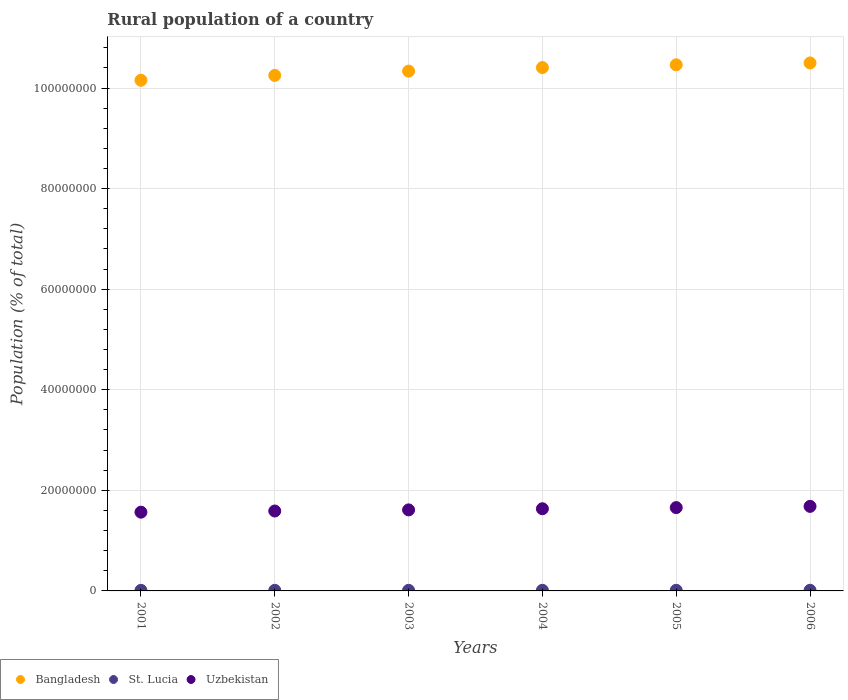How many different coloured dotlines are there?
Keep it short and to the point. 3. Is the number of dotlines equal to the number of legend labels?
Keep it short and to the point. Yes. What is the rural population in Bangladesh in 2004?
Make the answer very short. 1.04e+08. Across all years, what is the maximum rural population in St. Lucia?
Give a very brief answer. 1.31e+05. Across all years, what is the minimum rural population in Bangladesh?
Offer a terse response. 1.02e+08. In which year was the rural population in Bangladesh maximum?
Provide a short and direct response. 2006. What is the total rural population in Bangladesh in the graph?
Make the answer very short. 6.21e+08. What is the difference between the rural population in Bangladesh in 2002 and that in 2005?
Provide a short and direct response. -2.11e+06. What is the difference between the rural population in Uzbekistan in 2006 and the rural population in St. Lucia in 2005?
Your response must be concise. 1.67e+07. What is the average rural population in Uzbekistan per year?
Provide a short and direct response. 1.62e+07. In the year 2003, what is the difference between the rural population in Bangladesh and rural population in St. Lucia?
Your answer should be compact. 1.03e+08. In how many years, is the rural population in Uzbekistan greater than 84000000 %?
Your response must be concise. 0. What is the ratio of the rural population in Bangladesh in 2005 to that in 2006?
Your response must be concise. 1. Is the difference between the rural population in Bangladesh in 2004 and 2006 greater than the difference between the rural population in St. Lucia in 2004 and 2006?
Give a very brief answer. No. What is the difference between the highest and the second highest rural population in St. Lucia?
Ensure brevity in your answer.  3435. What is the difference between the highest and the lowest rural population in Uzbekistan?
Your response must be concise. 1.15e+06. Does the rural population in Bangladesh monotonically increase over the years?
Offer a terse response. Yes. How many years are there in the graph?
Make the answer very short. 6. Are the values on the major ticks of Y-axis written in scientific E-notation?
Your answer should be compact. No. Where does the legend appear in the graph?
Offer a terse response. Bottom left. What is the title of the graph?
Provide a succinct answer. Rural population of a country. Does "United Arab Emirates" appear as one of the legend labels in the graph?
Provide a succinct answer. No. What is the label or title of the Y-axis?
Offer a terse response. Population (% of total). What is the Population (% of total) of Bangladesh in 2001?
Provide a short and direct response. 1.02e+08. What is the Population (% of total) of St. Lucia in 2001?
Ensure brevity in your answer.  1.15e+05. What is the Population (% of total) of Uzbekistan in 2001?
Provide a short and direct response. 1.57e+07. What is the Population (% of total) of Bangladesh in 2002?
Ensure brevity in your answer.  1.03e+08. What is the Population (% of total) in St. Lucia in 2002?
Provide a succinct answer. 1.18e+05. What is the Population (% of total) of Uzbekistan in 2002?
Give a very brief answer. 1.59e+07. What is the Population (% of total) of Bangladesh in 2003?
Provide a succinct answer. 1.03e+08. What is the Population (% of total) of St. Lucia in 2003?
Ensure brevity in your answer.  1.21e+05. What is the Population (% of total) in Uzbekistan in 2003?
Keep it short and to the point. 1.61e+07. What is the Population (% of total) in Bangladesh in 2004?
Provide a short and direct response. 1.04e+08. What is the Population (% of total) of St. Lucia in 2004?
Your answer should be very brief. 1.24e+05. What is the Population (% of total) of Uzbekistan in 2004?
Ensure brevity in your answer.  1.63e+07. What is the Population (% of total) of Bangladesh in 2005?
Offer a terse response. 1.05e+08. What is the Population (% of total) in St. Lucia in 2005?
Provide a succinct answer. 1.27e+05. What is the Population (% of total) in Uzbekistan in 2005?
Your response must be concise. 1.66e+07. What is the Population (% of total) in Bangladesh in 2006?
Your answer should be compact. 1.05e+08. What is the Population (% of total) of St. Lucia in 2006?
Provide a succinct answer. 1.31e+05. What is the Population (% of total) of Uzbekistan in 2006?
Provide a succinct answer. 1.68e+07. Across all years, what is the maximum Population (% of total) in Bangladesh?
Your response must be concise. 1.05e+08. Across all years, what is the maximum Population (% of total) of St. Lucia?
Ensure brevity in your answer.  1.31e+05. Across all years, what is the maximum Population (% of total) of Uzbekistan?
Give a very brief answer. 1.68e+07. Across all years, what is the minimum Population (% of total) of Bangladesh?
Make the answer very short. 1.02e+08. Across all years, what is the minimum Population (% of total) in St. Lucia?
Your answer should be very brief. 1.15e+05. Across all years, what is the minimum Population (% of total) of Uzbekistan?
Ensure brevity in your answer.  1.57e+07. What is the total Population (% of total) in Bangladesh in the graph?
Ensure brevity in your answer.  6.21e+08. What is the total Population (% of total) in St. Lucia in the graph?
Provide a succinct answer. 7.36e+05. What is the total Population (% of total) of Uzbekistan in the graph?
Provide a succinct answer. 9.74e+07. What is the difference between the Population (% of total) in Bangladesh in 2001 and that in 2002?
Offer a very short reply. -9.62e+05. What is the difference between the Population (% of total) in St. Lucia in 2001 and that in 2002?
Offer a very short reply. -2970. What is the difference between the Population (% of total) of Uzbekistan in 2001 and that in 2002?
Keep it short and to the point. -2.31e+05. What is the difference between the Population (% of total) in Bangladesh in 2001 and that in 2003?
Provide a short and direct response. -1.81e+06. What is the difference between the Population (% of total) in St. Lucia in 2001 and that in 2003?
Offer a terse response. -5912. What is the difference between the Population (% of total) of Uzbekistan in 2001 and that in 2003?
Keep it short and to the point. -4.56e+05. What is the difference between the Population (% of total) in Bangladesh in 2001 and that in 2004?
Give a very brief answer. -2.52e+06. What is the difference between the Population (% of total) of St. Lucia in 2001 and that in 2004?
Ensure brevity in your answer.  -8950. What is the difference between the Population (% of total) of Uzbekistan in 2001 and that in 2004?
Make the answer very short. -6.81e+05. What is the difference between the Population (% of total) of Bangladesh in 2001 and that in 2005?
Your answer should be compact. -3.07e+06. What is the difference between the Population (% of total) of St. Lucia in 2001 and that in 2005?
Your answer should be very brief. -1.22e+04. What is the difference between the Population (% of total) in Uzbekistan in 2001 and that in 2005?
Provide a succinct answer. -9.12e+05. What is the difference between the Population (% of total) in Bangladesh in 2001 and that in 2006?
Offer a very short reply. -3.44e+06. What is the difference between the Population (% of total) of St. Lucia in 2001 and that in 2006?
Ensure brevity in your answer.  -1.56e+04. What is the difference between the Population (% of total) of Uzbekistan in 2001 and that in 2006?
Provide a short and direct response. -1.15e+06. What is the difference between the Population (% of total) in Bangladesh in 2002 and that in 2003?
Offer a very short reply. -8.52e+05. What is the difference between the Population (% of total) in St. Lucia in 2002 and that in 2003?
Your response must be concise. -2942. What is the difference between the Population (% of total) in Uzbekistan in 2002 and that in 2003?
Your response must be concise. -2.25e+05. What is the difference between the Population (% of total) in Bangladesh in 2002 and that in 2004?
Keep it short and to the point. -1.56e+06. What is the difference between the Population (% of total) of St. Lucia in 2002 and that in 2004?
Your answer should be compact. -5980. What is the difference between the Population (% of total) of Uzbekistan in 2002 and that in 2004?
Provide a short and direct response. -4.50e+05. What is the difference between the Population (% of total) in Bangladesh in 2002 and that in 2005?
Provide a succinct answer. -2.11e+06. What is the difference between the Population (% of total) of St. Lucia in 2002 and that in 2005?
Provide a short and direct response. -9189. What is the difference between the Population (% of total) in Uzbekistan in 2002 and that in 2005?
Make the answer very short. -6.81e+05. What is the difference between the Population (% of total) in Bangladesh in 2002 and that in 2006?
Your answer should be compact. -2.48e+06. What is the difference between the Population (% of total) in St. Lucia in 2002 and that in 2006?
Your answer should be compact. -1.26e+04. What is the difference between the Population (% of total) in Uzbekistan in 2002 and that in 2006?
Make the answer very short. -9.24e+05. What is the difference between the Population (% of total) in Bangladesh in 2003 and that in 2004?
Make the answer very short. -7.08e+05. What is the difference between the Population (% of total) of St. Lucia in 2003 and that in 2004?
Provide a succinct answer. -3038. What is the difference between the Population (% of total) of Uzbekistan in 2003 and that in 2004?
Keep it short and to the point. -2.26e+05. What is the difference between the Population (% of total) in Bangladesh in 2003 and that in 2005?
Offer a very short reply. -1.26e+06. What is the difference between the Population (% of total) of St. Lucia in 2003 and that in 2005?
Offer a very short reply. -6247. What is the difference between the Population (% of total) in Uzbekistan in 2003 and that in 2005?
Keep it short and to the point. -4.56e+05. What is the difference between the Population (% of total) in Bangladesh in 2003 and that in 2006?
Provide a short and direct response. -1.63e+06. What is the difference between the Population (% of total) in St. Lucia in 2003 and that in 2006?
Offer a terse response. -9682. What is the difference between the Population (% of total) in Uzbekistan in 2003 and that in 2006?
Make the answer very short. -6.99e+05. What is the difference between the Population (% of total) in Bangladesh in 2004 and that in 2005?
Your response must be concise. -5.48e+05. What is the difference between the Population (% of total) in St. Lucia in 2004 and that in 2005?
Your answer should be compact. -3209. What is the difference between the Population (% of total) of Uzbekistan in 2004 and that in 2005?
Give a very brief answer. -2.30e+05. What is the difference between the Population (% of total) in Bangladesh in 2004 and that in 2006?
Give a very brief answer. -9.20e+05. What is the difference between the Population (% of total) in St. Lucia in 2004 and that in 2006?
Keep it short and to the point. -6644. What is the difference between the Population (% of total) of Uzbekistan in 2004 and that in 2006?
Your answer should be compact. -4.74e+05. What is the difference between the Population (% of total) in Bangladesh in 2005 and that in 2006?
Ensure brevity in your answer.  -3.72e+05. What is the difference between the Population (% of total) in St. Lucia in 2005 and that in 2006?
Your response must be concise. -3435. What is the difference between the Population (% of total) in Uzbekistan in 2005 and that in 2006?
Provide a succinct answer. -2.43e+05. What is the difference between the Population (% of total) in Bangladesh in 2001 and the Population (% of total) in St. Lucia in 2002?
Provide a succinct answer. 1.01e+08. What is the difference between the Population (% of total) in Bangladesh in 2001 and the Population (% of total) in Uzbekistan in 2002?
Keep it short and to the point. 8.57e+07. What is the difference between the Population (% of total) of St. Lucia in 2001 and the Population (% of total) of Uzbekistan in 2002?
Your answer should be very brief. -1.58e+07. What is the difference between the Population (% of total) in Bangladesh in 2001 and the Population (% of total) in St. Lucia in 2003?
Your answer should be very brief. 1.01e+08. What is the difference between the Population (% of total) in Bangladesh in 2001 and the Population (% of total) in Uzbekistan in 2003?
Provide a succinct answer. 8.54e+07. What is the difference between the Population (% of total) of St. Lucia in 2001 and the Population (% of total) of Uzbekistan in 2003?
Ensure brevity in your answer.  -1.60e+07. What is the difference between the Population (% of total) in Bangladesh in 2001 and the Population (% of total) in St. Lucia in 2004?
Offer a very short reply. 1.01e+08. What is the difference between the Population (% of total) of Bangladesh in 2001 and the Population (% of total) of Uzbekistan in 2004?
Offer a terse response. 8.52e+07. What is the difference between the Population (% of total) of St. Lucia in 2001 and the Population (% of total) of Uzbekistan in 2004?
Your response must be concise. -1.62e+07. What is the difference between the Population (% of total) of Bangladesh in 2001 and the Population (% of total) of St. Lucia in 2005?
Your answer should be very brief. 1.01e+08. What is the difference between the Population (% of total) in Bangladesh in 2001 and the Population (% of total) in Uzbekistan in 2005?
Your answer should be very brief. 8.50e+07. What is the difference between the Population (% of total) of St. Lucia in 2001 and the Population (% of total) of Uzbekistan in 2005?
Give a very brief answer. -1.65e+07. What is the difference between the Population (% of total) in Bangladesh in 2001 and the Population (% of total) in St. Lucia in 2006?
Make the answer very short. 1.01e+08. What is the difference between the Population (% of total) of Bangladesh in 2001 and the Population (% of total) of Uzbekistan in 2006?
Make the answer very short. 8.47e+07. What is the difference between the Population (% of total) of St. Lucia in 2001 and the Population (% of total) of Uzbekistan in 2006?
Your answer should be compact. -1.67e+07. What is the difference between the Population (% of total) of Bangladesh in 2002 and the Population (% of total) of St. Lucia in 2003?
Offer a very short reply. 1.02e+08. What is the difference between the Population (% of total) in Bangladesh in 2002 and the Population (% of total) in Uzbekistan in 2003?
Keep it short and to the point. 8.64e+07. What is the difference between the Population (% of total) of St. Lucia in 2002 and the Population (% of total) of Uzbekistan in 2003?
Keep it short and to the point. -1.60e+07. What is the difference between the Population (% of total) in Bangladesh in 2002 and the Population (% of total) in St. Lucia in 2004?
Ensure brevity in your answer.  1.02e+08. What is the difference between the Population (% of total) in Bangladesh in 2002 and the Population (% of total) in Uzbekistan in 2004?
Keep it short and to the point. 8.62e+07. What is the difference between the Population (% of total) of St. Lucia in 2002 and the Population (% of total) of Uzbekistan in 2004?
Your answer should be compact. -1.62e+07. What is the difference between the Population (% of total) of Bangladesh in 2002 and the Population (% of total) of St. Lucia in 2005?
Ensure brevity in your answer.  1.02e+08. What is the difference between the Population (% of total) of Bangladesh in 2002 and the Population (% of total) of Uzbekistan in 2005?
Offer a very short reply. 8.59e+07. What is the difference between the Population (% of total) in St. Lucia in 2002 and the Population (% of total) in Uzbekistan in 2005?
Ensure brevity in your answer.  -1.65e+07. What is the difference between the Population (% of total) of Bangladesh in 2002 and the Population (% of total) of St. Lucia in 2006?
Make the answer very short. 1.02e+08. What is the difference between the Population (% of total) in Bangladesh in 2002 and the Population (% of total) in Uzbekistan in 2006?
Your answer should be compact. 8.57e+07. What is the difference between the Population (% of total) in St. Lucia in 2002 and the Population (% of total) in Uzbekistan in 2006?
Offer a terse response. -1.67e+07. What is the difference between the Population (% of total) in Bangladesh in 2003 and the Population (% of total) in St. Lucia in 2004?
Provide a short and direct response. 1.03e+08. What is the difference between the Population (% of total) in Bangladesh in 2003 and the Population (% of total) in Uzbekistan in 2004?
Provide a succinct answer. 8.70e+07. What is the difference between the Population (% of total) of St. Lucia in 2003 and the Population (% of total) of Uzbekistan in 2004?
Keep it short and to the point. -1.62e+07. What is the difference between the Population (% of total) of Bangladesh in 2003 and the Population (% of total) of St. Lucia in 2005?
Make the answer very short. 1.03e+08. What is the difference between the Population (% of total) of Bangladesh in 2003 and the Population (% of total) of Uzbekistan in 2005?
Keep it short and to the point. 8.68e+07. What is the difference between the Population (% of total) in St. Lucia in 2003 and the Population (% of total) in Uzbekistan in 2005?
Offer a very short reply. -1.64e+07. What is the difference between the Population (% of total) of Bangladesh in 2003 and the Population (% of total) of St. Lucia in 2006?
Your answer should be very brief. 1.03e+08. What is the difference between the Population (% of total) in Bangladesh in 2003 and the Population (% of total) in Uzbekistan in 2006?
Offer a very short reply. 8.65e+07. What is the difference between the Population (% of total) in St. Lucia in 2003 and the Population (% of total) in Uzbekistan in 2006?
Offer a terse response. -1.67e+07. What is the difference between the Population (% of total) in Bangladesh in 2004 and the Population (% of total) in St. Lucia in 2005?
Provide a short and direct response. 1.04e+08. What is the difference between the Population (% of total) of Bangladesh in 2004 and the Population (% of total) of Uzbekistan in 2005?
Provide a short and direct response. 8.75e+07. What is the difference between the Population (% of total) in St. Lucia in 2004 and the Population (% of total) in Uzbekistan in 2005?
Your answer should be very brief. -1.64e+07. What is the difference between the Population (% of total) of Bangladesh in 2004 and the Population (% of total) of St. Lucia in 2006?
Provide a short and direct response. 1.04e+08. What is the difference between the Population (% of total) of Bangladesh in 2004 and the Population (% of total) of Uzbekistan in 2006?
Your response must be concise. 8.73e+07. What is the difference between the Population (% of total) of St. Lucia in 2004 and the Population (% of total) of Uzbekistan in 2006?
Provide a succinct answer. -1.67e+07. What is the difference between the Population (% of total) in Bangladesh in 2005 and the Population (% of total) in St. Lucia in 2006?
Provide a succinct answer. 1.04e+08. What is the difference between the Population (% of total) of Bangladesh in 2005 and the Population (% of total) of Uzbekistan in 2006?
Give a very brief answer. 8.78e+07. What is the difference between the Population (% of total) in St. Lucia in 2005 and the Population (% of total) in Uzbekistan in 2006?
Your answer should be very brief. -1.67e+07. What is the average Population (% of total) in Bangladesh per year?
Your answer should be compact. 1.04e+08. What is the average Population (% of total) in St. Lucia per year?
Give a very brief answer. 1.23e+05. What is the average Population (% of total) in Uzbekistan per year?
Ensure brevity in your answer.  1.62e+07. In the year 2001, what is the difference between the Population (% of total) of Bangladesh and Population (% of total) of St. Lucia?
Your answer should be compact. 1.01e+08. In the year 2001, what is the difference between the Population (% of total) in Bangladesh and Population (% of total) in Uzbekistan?
Your response must be concise. 8.59e+07. In the year 2001, what is the difference between the Population (% of total) of St. Lucia and Population (% of total) of Uzbekistan?
Offer a terse response. -1.55e+07. In the year 2002, what is the difference between the Population (% of total) of Bangladesh and Population (% of total) of St. Lucia?
Provide a short and direct response. 1.02e+08. In the year 2002, what is the difference between the Population (% of total) of Bangladesh and Population (% of total) of Uzbekistan?
Offer a terse response. 8.66e+07. In the year 2002, what is the difference between the Population (% of total) in St. Lucia and Population (% of total) in Uzbekistan?
Give a very brief answer. -1.58e+07. In the year 2003, what is the difference between the Population (% of total) of Bangladesh and Population (% of total) of St. Lucia?
Your response must be concise. 1.03e+08. In the year 2003, what is the difference between the Population (% of total) in Bangladesh and Population (% of total) in Uzbekistan?
Offer a terse response. 8.72e+07. In the year 2003, what is the difference between the Population (% of total) in St. Lucia and Population (% of total) in Uzbekistan?
Give a very brief answer. -1.60e+07. In the year 2004, what is the difference between the Population (% of total) of Bangladesh and Population (% of total) of St. Lucia?
Keep it short and to the point. 1.04e+08. In the year 2004, what is the difference between the Population (% of total) in Bangladesh and Population (% of total) in Uzbekistan?
Give a very brief answer. 8.77e+07. In the year 2004, what is the difference between the Population (% of total) of St. Lucia and Population (% of total) of Uzbekistan?
Keep it short and to the point. -1.62e+07. In the year 2005, what is the difference between the Population (% of total) of Bangladesh and Population (% of total) of St. Lucia?
Your answer should be very brief. 1.04e+08. In the year 2005, what is the difference between the Population (% of total) of Bangladesh and Population (% of total) of Uzbekistan?
Provide a short and direct response. 8.80e+07. In the year 2005, what is the difference between the Population (% of total) in St. Lucia and Population (% of total) in Uzbekistan?
Offer a terse response. -1.64e+07. In the year 2006, what is the difference between the Population (% of total) in Bangladesh and Population (% of total) in St. Lucia?
Your answer should be very brief. 1.05e+08. In the year 2006, what is the difference between the Population (% of total) of Bangladesh and Population (% of total) of Uzbekistan?
Your answer should be very brief. 8.82e+07. In the year 2006, what is the difference between the Population (% of total) of St. Lucia and Population (% of total) of Uzbekistan?
Ensure brevity in your answer.  -1.67e+07. What is the ratio of the Population (% of total) in Bangladesh in 2001 to that in 2002?
Give a very brief answer. 0.99. What is the ratio of the Population (% of total) in St. Lucia in 2001 to that in 2002?
Your response must be concise. 0.97. What is the ratio of the Population (% of total) in Uzbekistan in 2001 to that in 2002?
Provide a short and direct response. 0.99. What is the ratio of the Population (% of total) of Bangladesh in 2001 to that in 2003?
Keep it short and to the point. 0.98. What is the ratio of the Population (% of total) in St. Lucia in 2001 to that in 2003?
Give a very brief answer. 0.95. What is the ratio of the Population (% of total) in Uzbekistan in 2001 to that in 2003?
Ensure brevity in your answer.  0.97. What is the ratio of the Population (% of total) in Bangladesh in 2001 to that in 2004?
Keep it short and to the point. 0.98. What is the ratio of the Population (% of total) of St. Lucia in 2001 to that in 2004?
Your response must be concise. 0.93. What is the ratio of the Population (% of total) of Bangladesh in 2001 to that in 2005?
Your answer should be compact. 0.97. What is the ratio of the Population (% of total) of St. Lucia in 2001 to that in 2005?
Give a very brief answer. 0.9. What is the ratio of the Population (% of total) of Uzbekistan in 2001 to that in 2005?
Provide a short and direct response. 0.94. What is the ratio of the Population (% of total) of Bangladesh in 2001 to that in 2006?
Give a very brief answer. 0.97. What is the ratio of the Population (% of total) in St. Lucia in 2001 to that in 2006?
Keep it short and to the point. 0.88. What is the ratio of the Population (% of total) of Uzbekistan in 2001 to that in 2006?
Provide a short and direct response. 0.93. What is the ratio of the Population (% of total) in Bangladesh in 2002 to that in 2003?
Provide a short and direct response. 0.99. What is the ratio of the Population (% of total) of St. Lucia in 2002 to that in 2003?
Offer a very short reply. 0.98. What is the ratio of the Population (% of total) in Uzbekistan in 2002 to that in 2003?
Provide a short and direct response. 0.99. What is the ratio of the Population (% of total) of St. Lucia in 2002 to that in 2004?
Your response must be concise. 0.95. What is the ratio of the Population (% of total) in Uzbekistan in 2002 to that in 2004?
Keep it short and to the point. 0.97. What is the ratio of the Population (% of total) in Bangladesh in 2002 to that in 2005?
Make the answer very short. 0.98. What is the ratio of the Population (% of total) in St. Lucia in 2002 to that in 2005?
Offer a terse response. 0.93. What is the ratio of the Population (% of total) of Uzbekistan in 2002 to that in 2005?
Your response must be concise. 0.96. What is the ratio of the Population (% of total) of Bangladesh in 2002 to that in 2006?
Provide a succinct answer. 0.98. What is the ratio of the Population (% of total) of St. Lucia in 2002 to that in 2006?
Make the answer very short. 0.9. What is the ratio of the Population (% of total) in Uzbekistan in 2002 to that in 2006?
Keep it short and to the point. 0.94. What is the ratio of the Population (% of total) of St. Lucia in 2003 to that in 2004?
Offer a very short reply. 0.98. What is the ratio of the Population (% of total) of Uzbekistan in 2003 to that in 2004?
Provide a succinct answer. 0.99. What is the ratio of the Population (% of total) in St. Lucia in 2003 to that in 2005?
Ensure brevity in your answer.  0.95. What is the ratio of the Population (% of total) in Uzbekistan in 2003 to that in 2005?
Provide a short and direct response. 0.97. What is the ratio of the Population (% of total) in Bangladesh in 2003 to that in 2006?
Ensure brevity in your answer.  0.98. What is the ratio of the Population (% of total) in St. Lucia in 2003 to that in 2006?
Offer a very short reply. 0.93. What is the ratio of the Population (% of total) in Uzbekistan in 2003 to that in 2006?
Keep it short and to the point. 0.96. What is the ratio of the Population (% of total) of Bangladesh in 2004 to that in 2005?
Your answer should be compact. 0.99. What is the ratio of the Population (% of total) in St. Lucia in 2004 to that in 2005?
Provide a short and direct response. 0.97. What is the ratio of the Population (% of total) in Uzbekistan in 2004 to that in 2005?
Make the answer very short. 0.99. What is the ratio of the Population (% of total) of Bangladesh in 2004 to that in 2006?
Give a very brief answer. 0.99. What is the ratio of the Population (% of total) of St. Lucia in 2004 to that in 2006?
Provide a succinct answer. 0.95. What is the ratio of the Population (% of total) in Uzbekistan in 2004 to that in 2006?
Keep it short and to the point. 0.97. What is the ratio of the Population (% of total) in St. Lucia in 2005 to that in 2006?
Your answer should be compact. 0.97. What is the ratio of the Population (% of total) of Uzbekistan in 2005 to that in 2006?
Ensure brevity in your answer.  0.99. What is the difference between the highest and the second highest Population (% of total) in Bangladesh?
Provide a short and direct response. 3.72e+05. What is the difference between the highest and the second highest Population (% of total) in St. Lucia?
Your answer should be compact. 3435. What is the difference between the highest and the second highest Population (% of total) of Uzbekistan?
Provide a succinct answer. 2.43e+05. What is the difference between the highest and the lowest Population (% of total) of Bangladesh?
Give a very brief answer. 3.44e+06. What is the difference between the highest and the lowest Population (% of total) in St. Lucia?
Provide a succinct answer. 1.56e+04. What is the difference between the highest and the lowest Population (% of total) in Uzbekistan?
Offer a very short reply. 1.15e+06. 